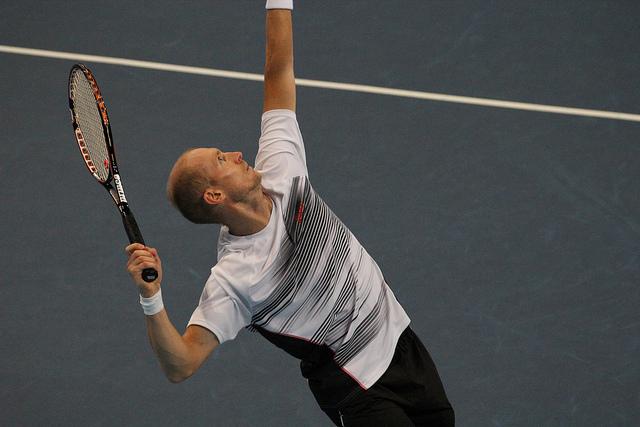Where is the racket?
Answer briefly. Right hand. What sport is being played?
Short answer required. Tennis. What brand is the man's shirt?
Give a very brief answer. Nike. 